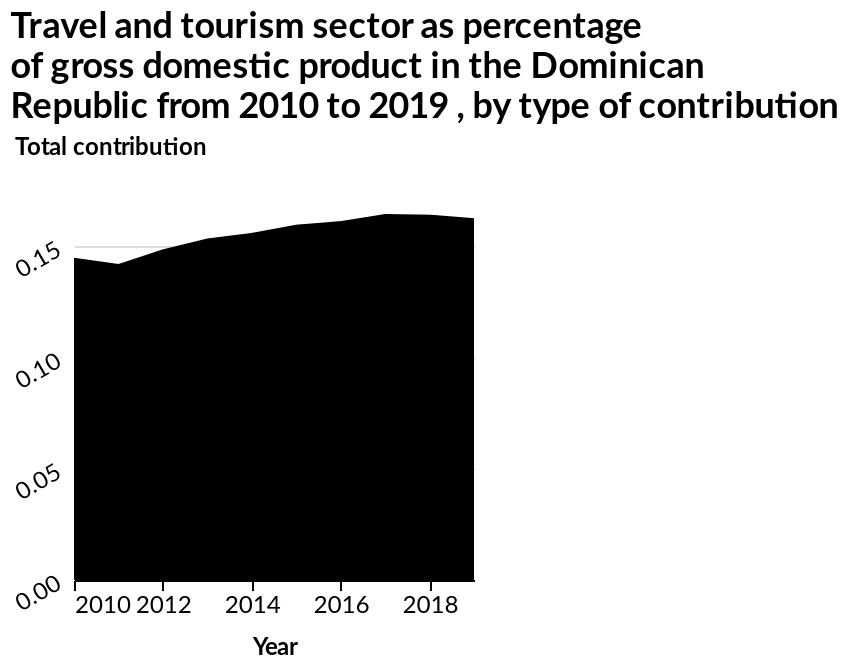<image>
Offer a thorough analysis of the image. Travel and tourism has been steadily increasing since 2012. Tourism makes up roughly 15 to 16% of the GDP of the Dominican Republic. What has been the trend in travel and tourism since 2012?  Travel and tourism has been steadily increasing since 2012. What is the subject of the area plot in the given figure? The subject of the area plot is the travel and tourism sector as a percentage of gross domestic product in the Dominican Republic. 